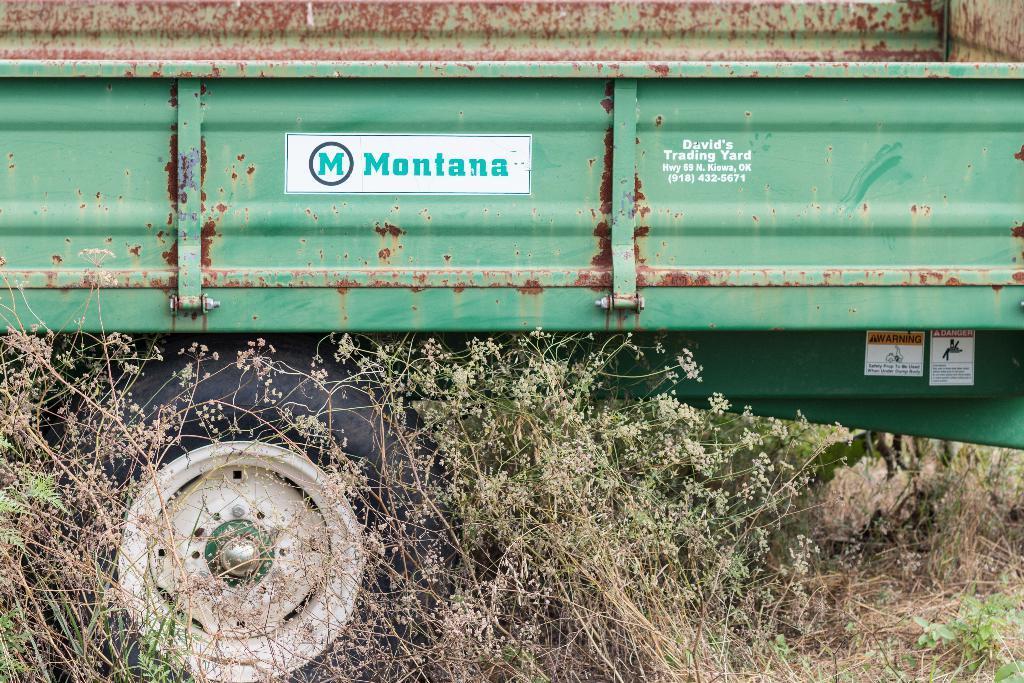In one or two sentences, can you explain what this image depicts? In this image, this looks like a truck, which is green in color. This is a wheel. I can see the plants and grass. These are the stickers attached to the truck. 